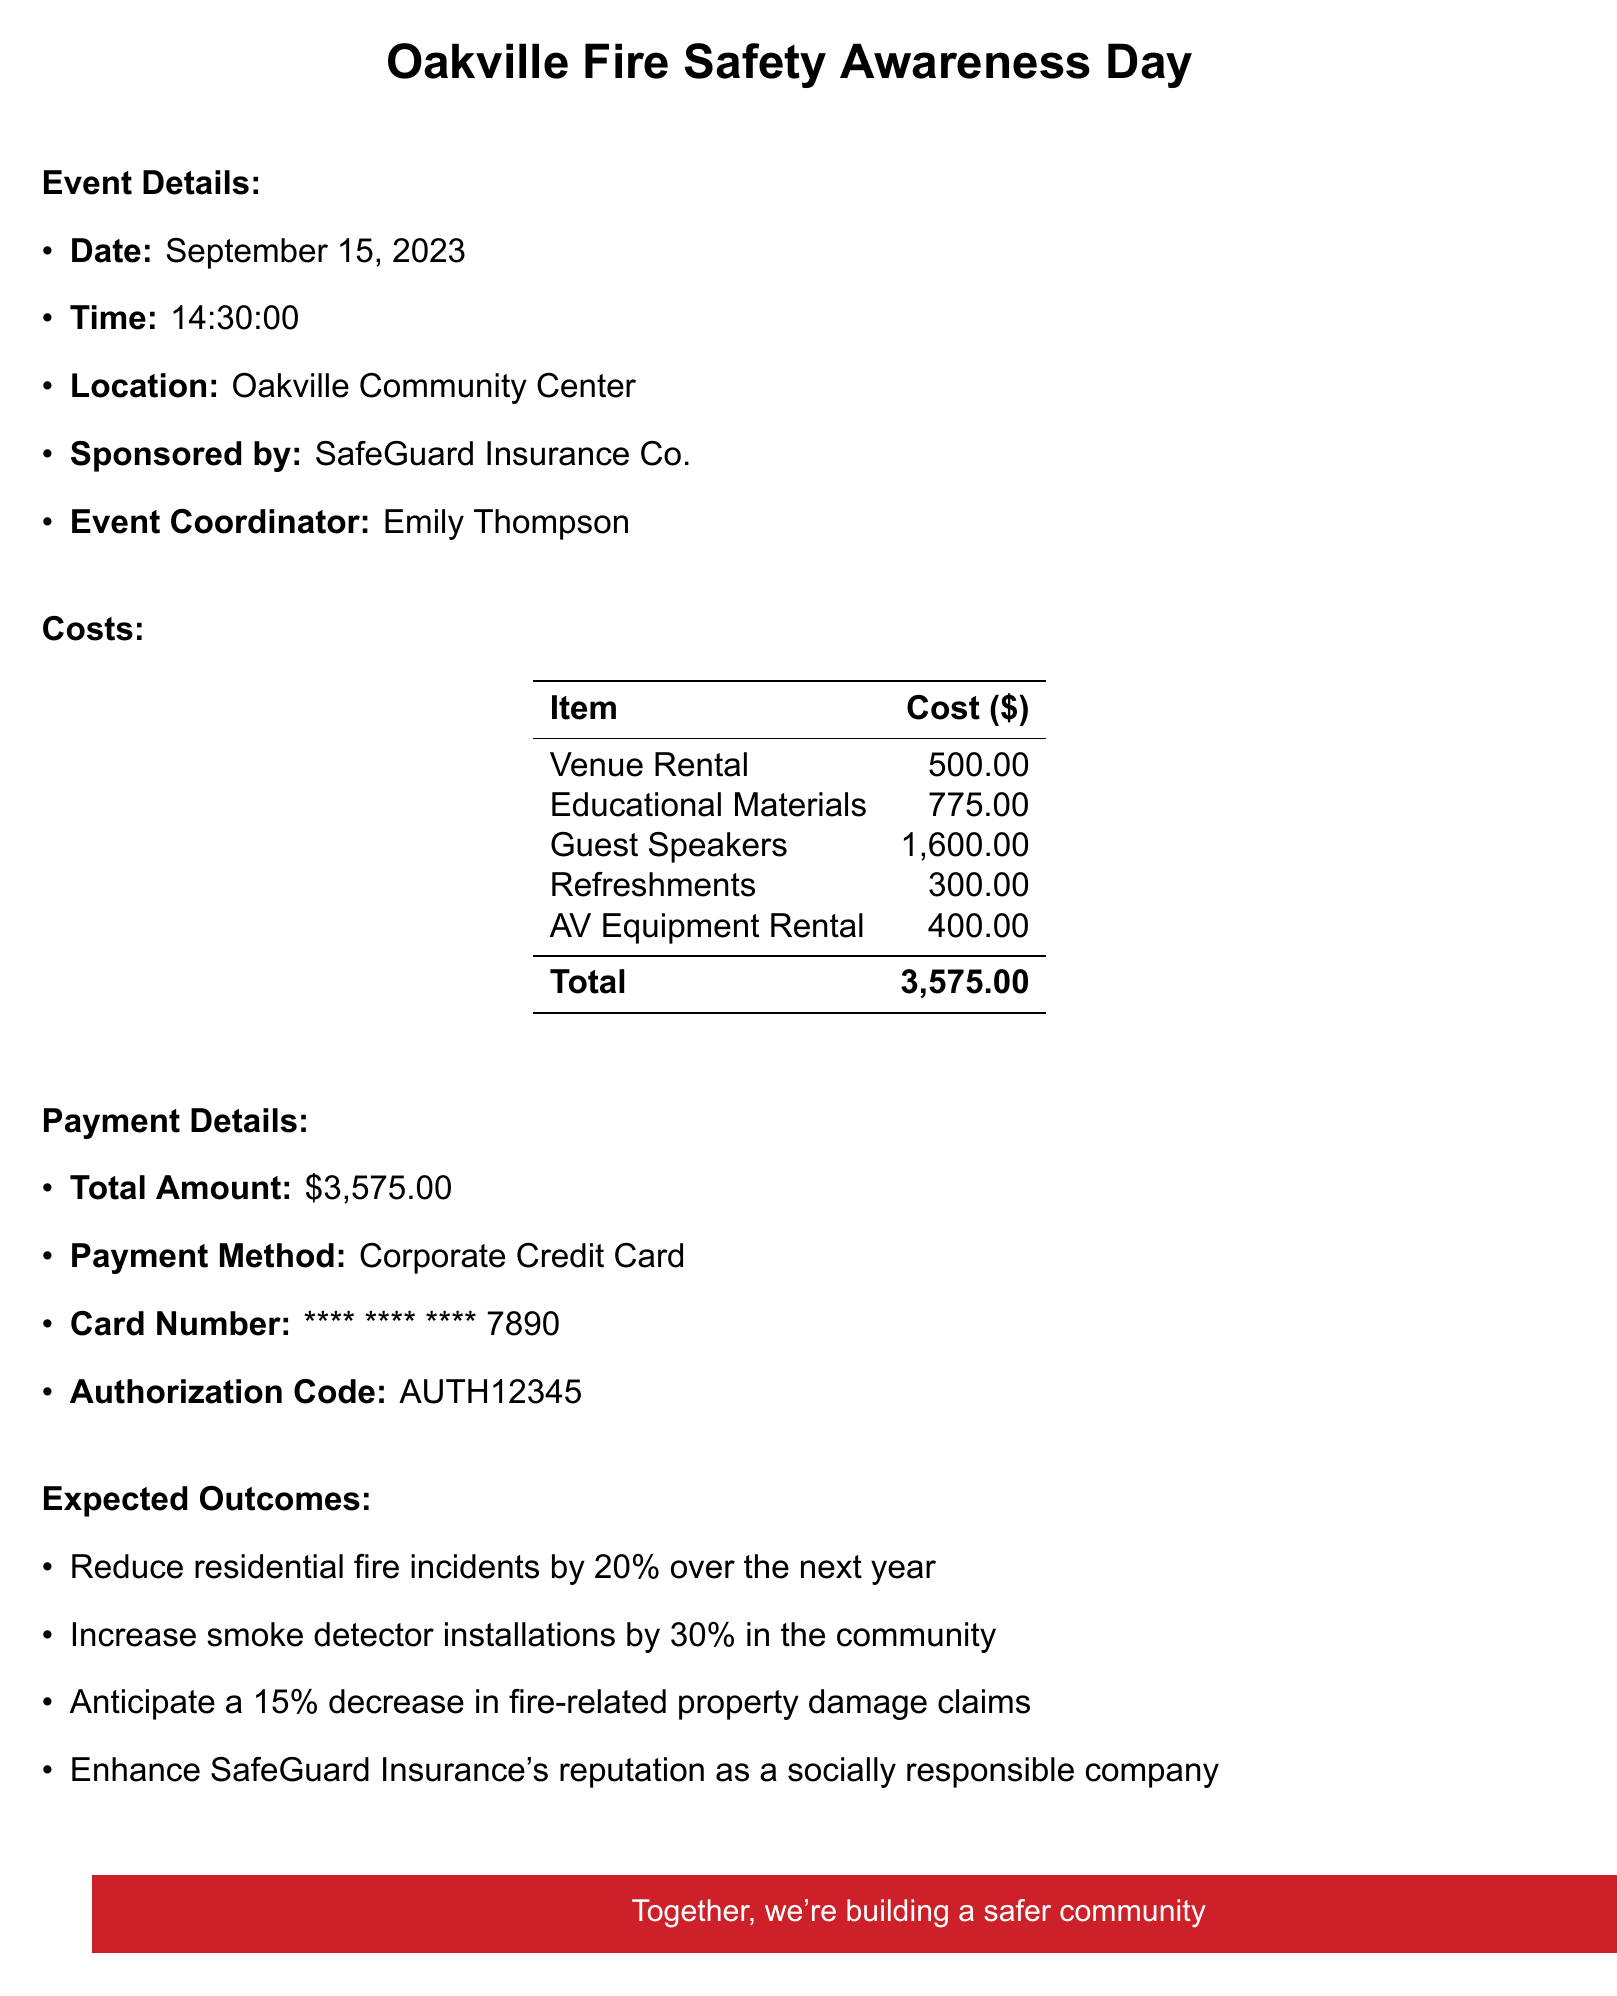what is the date of the event? The event is scheduled for September 15, 2023, as stated in the document.
Answer: September 15, 2023 who is the event coordinator? The event coordinator is mentioned in the document as Emily Thompson.
Answer: Emily Thompson what is the total amount paid for this event? The total amount reflects the sum of all costs listed in the document, which is $3,575.00.
Answer: 3,575.00 how much did the educational materials cost? The document specifies the total cost for educational materials as $775.00.
Answer: 775.00 who is one of the guest speakers at the event? The document lists multiple guest speakers, one of whom is Chief John Martinez.
Answer: Chief John Martinez what is one expected outcome of the event? The expected outcomes include reducing residential fire incidents by 20% over the next year, as stated in the document.
Answer: Reduce residential fire incidents by 20% what location is the event held? The event's location is specified as the Oakville Community Center in the document.
Answer: Oakville Community Center how much was spent on refreshments? The document details that the cost for refreshments was $300.00.
Answer: 300.00 what method was used for payment? The document indicates that a Corporate Credit Card was used for the payment.
Answer: Corporate Credit Card 